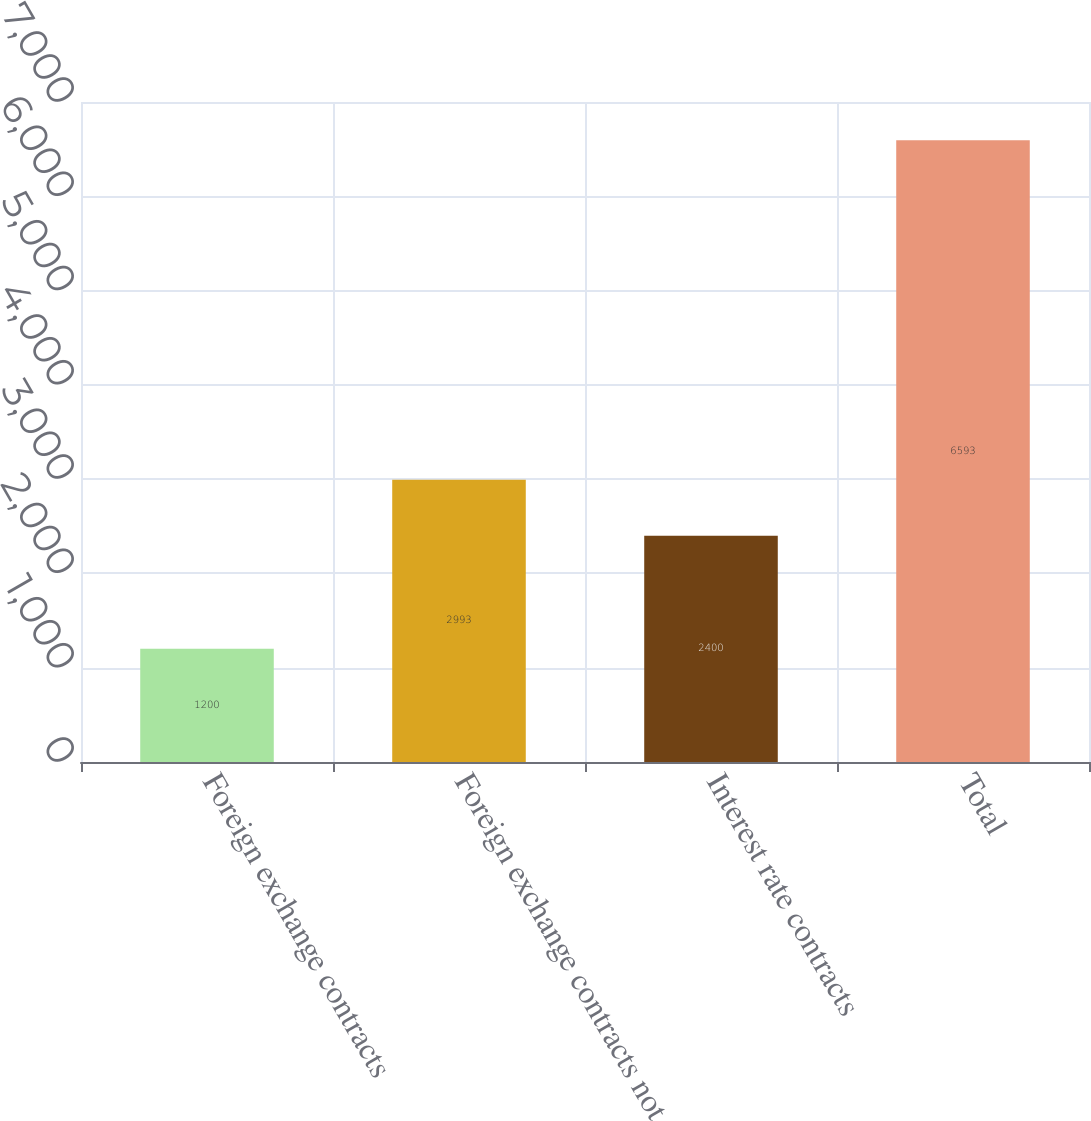<chart> <loc_0><loc_0><loc_500><loc_500><bar_chart><fcel>Foreign exchange contracts<fcel>Foreign exchange contracts not<fcel>Interest rate contracts<fcel>Total<nl><fcel>1200<fcel>2993<fcel>2400<fcel>6593<nl></chart> 